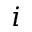Convert formula to latex. <formula><loc_0><loc_0><loc_500><loc_500>i</formula> 